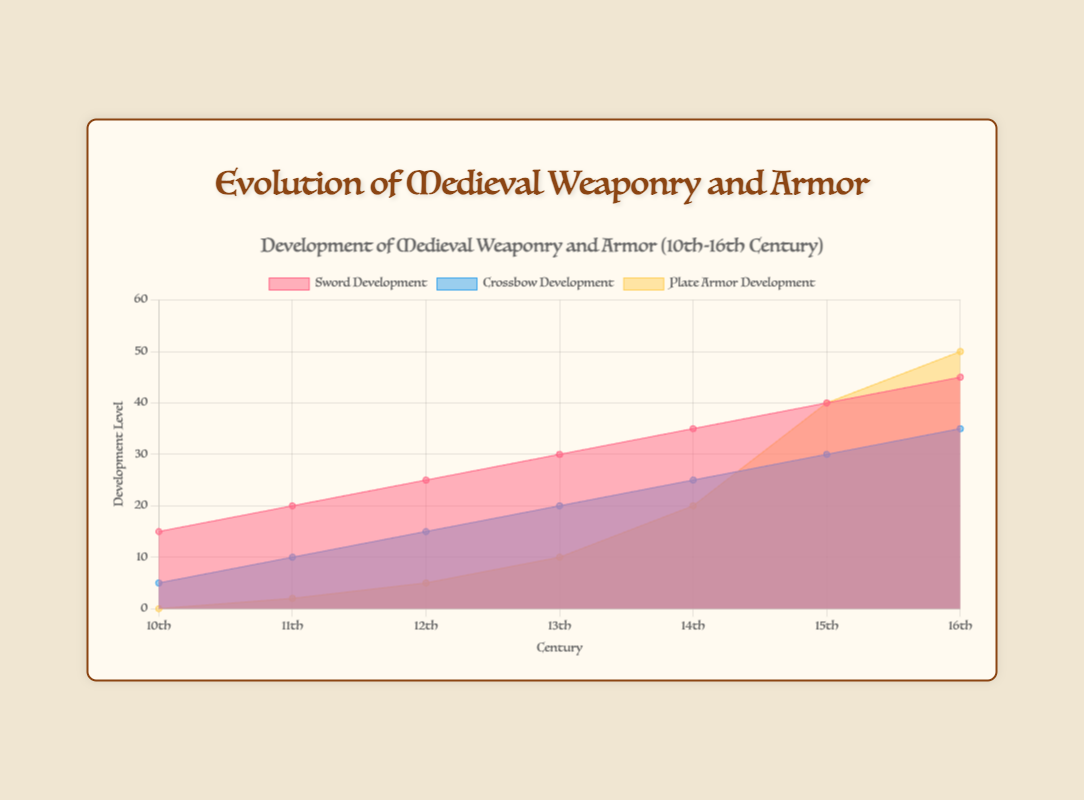What is the title of the chart? The title is located at the top center of the chart. It provides a summary of the content of the chart. The title reads, "Development of Medieval Weaponry and Armor (10th-16th Century)."
Answer: Development of Medieval Weaponry and Armor (10th-16th Century) What does the y-axis represent? The y-axis is titled "Development Level" and indicates the level of development for each type of weaponry and armor across different centuries.
Answer: Development Level Which century saw the highest development in plate armor? By examining the plot representing plate armor development, we can observe that it peaked in the 16th century.
Answer: 16th century How many data points are plotted for sword development? The x-axis shows the centuries ranging from the 10th to the 16th, so counting the corresponding data points for sword development will give us seven points.
Answer: Seven Compare the sword and crossbow development levels in the 13th century. Which one is higher and by how much? For the 13th-century data points, the sword development level is 30, and the crossbow development level is 20. The difference is calculated as 30 - 20.
Answer: Sword development is higher by 10 What is the average development level of crossbows over the centuries plotted? The development levels for crossbows are 5, 10, 15, 20, 25, 30, and 35. Summing these values and dividing by the number of centuries (7) gives the average: (5+10+15+20+25+30+35)/7.
Answer: 20 In which century do we first see the introduction of plate armor development? The first non-zero value in the plate armor series appears in the 11th century, indicating the introduction of plate armor development.
Answer: 11th century Is there any century where the development levels of all three categories (sword, crossbow, and plate armor) increase compared to the previous century? We need to check if for any century, the values for sword development, crossbow development, and plate armor development are all greater than in the previous century. From the 10th to the 11th, 11th to 12th, 12th to 13th, 13th to 14th, and 14th to 15th, all three categories see an increase.
Answer: Yes, multiple instances What is the combined development level of sword and crossbow in the 12th century? For the 12th century, the sword development is 25, and the crossbow development is 15. The combined development level is calculated as 25 + 15.
Answer: 40 